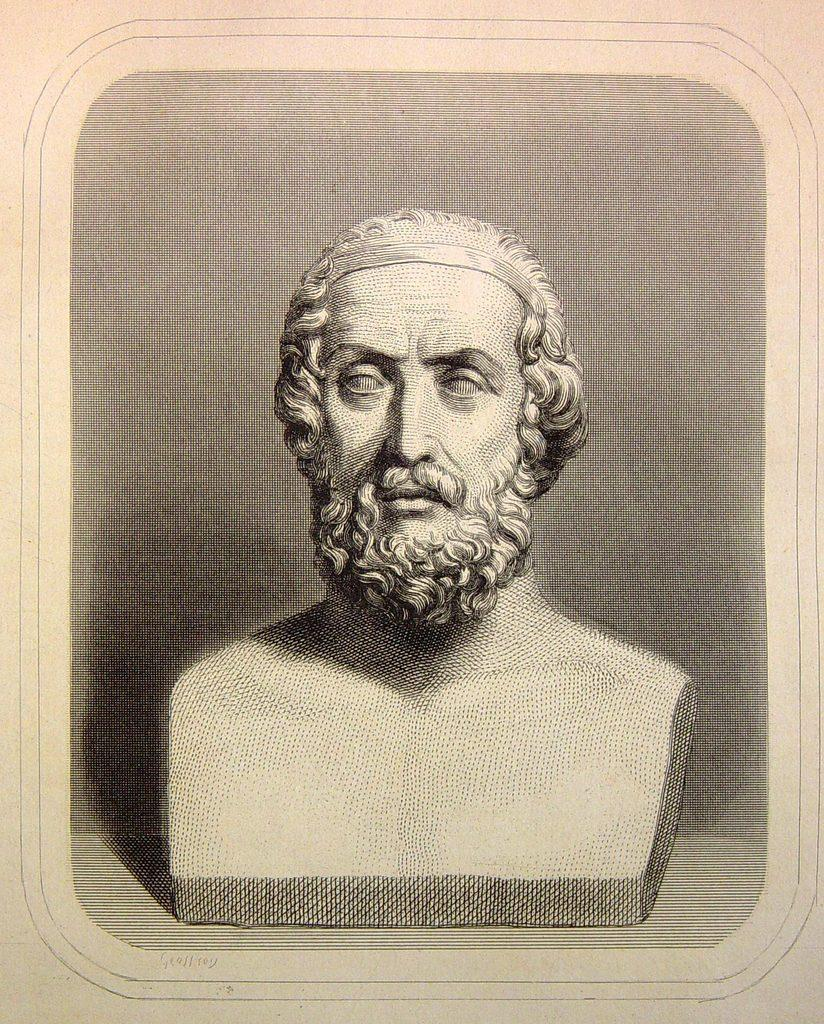What is the main subject of the image? The main subject of the image is a photo of a sculpture. What type of advice can be seen in the image? There is no advice present in the image; it features a photo of a sculpture. Can you describe the jellyfish in the image? There are no jellyfish present in the image; it features a photo of a sculpture. 